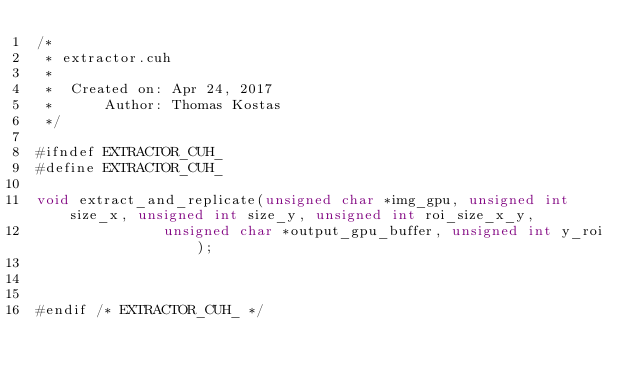Convert code to text. <code><loc_0><loc_0><loc_500><loc_500><_Cuda_>/*
 * extractor.cuh
 *
 *  Created on: Apr 24, 2017
 *      Author: Thomas Kostas
 */

#ifndef EXTRACTOR_CUH_
#define EXTRACTOR_CUH_

void extract_and_replicate(unsigned char *img_gpu, unsigned int size_x, unsigned int size_y, unsigned int roi_size_x_y,
						   unsigned char *output_gpu_buffer, unsigned int y_roi);



#endif /* EXTRACTOR_CUH_ */
</code> 